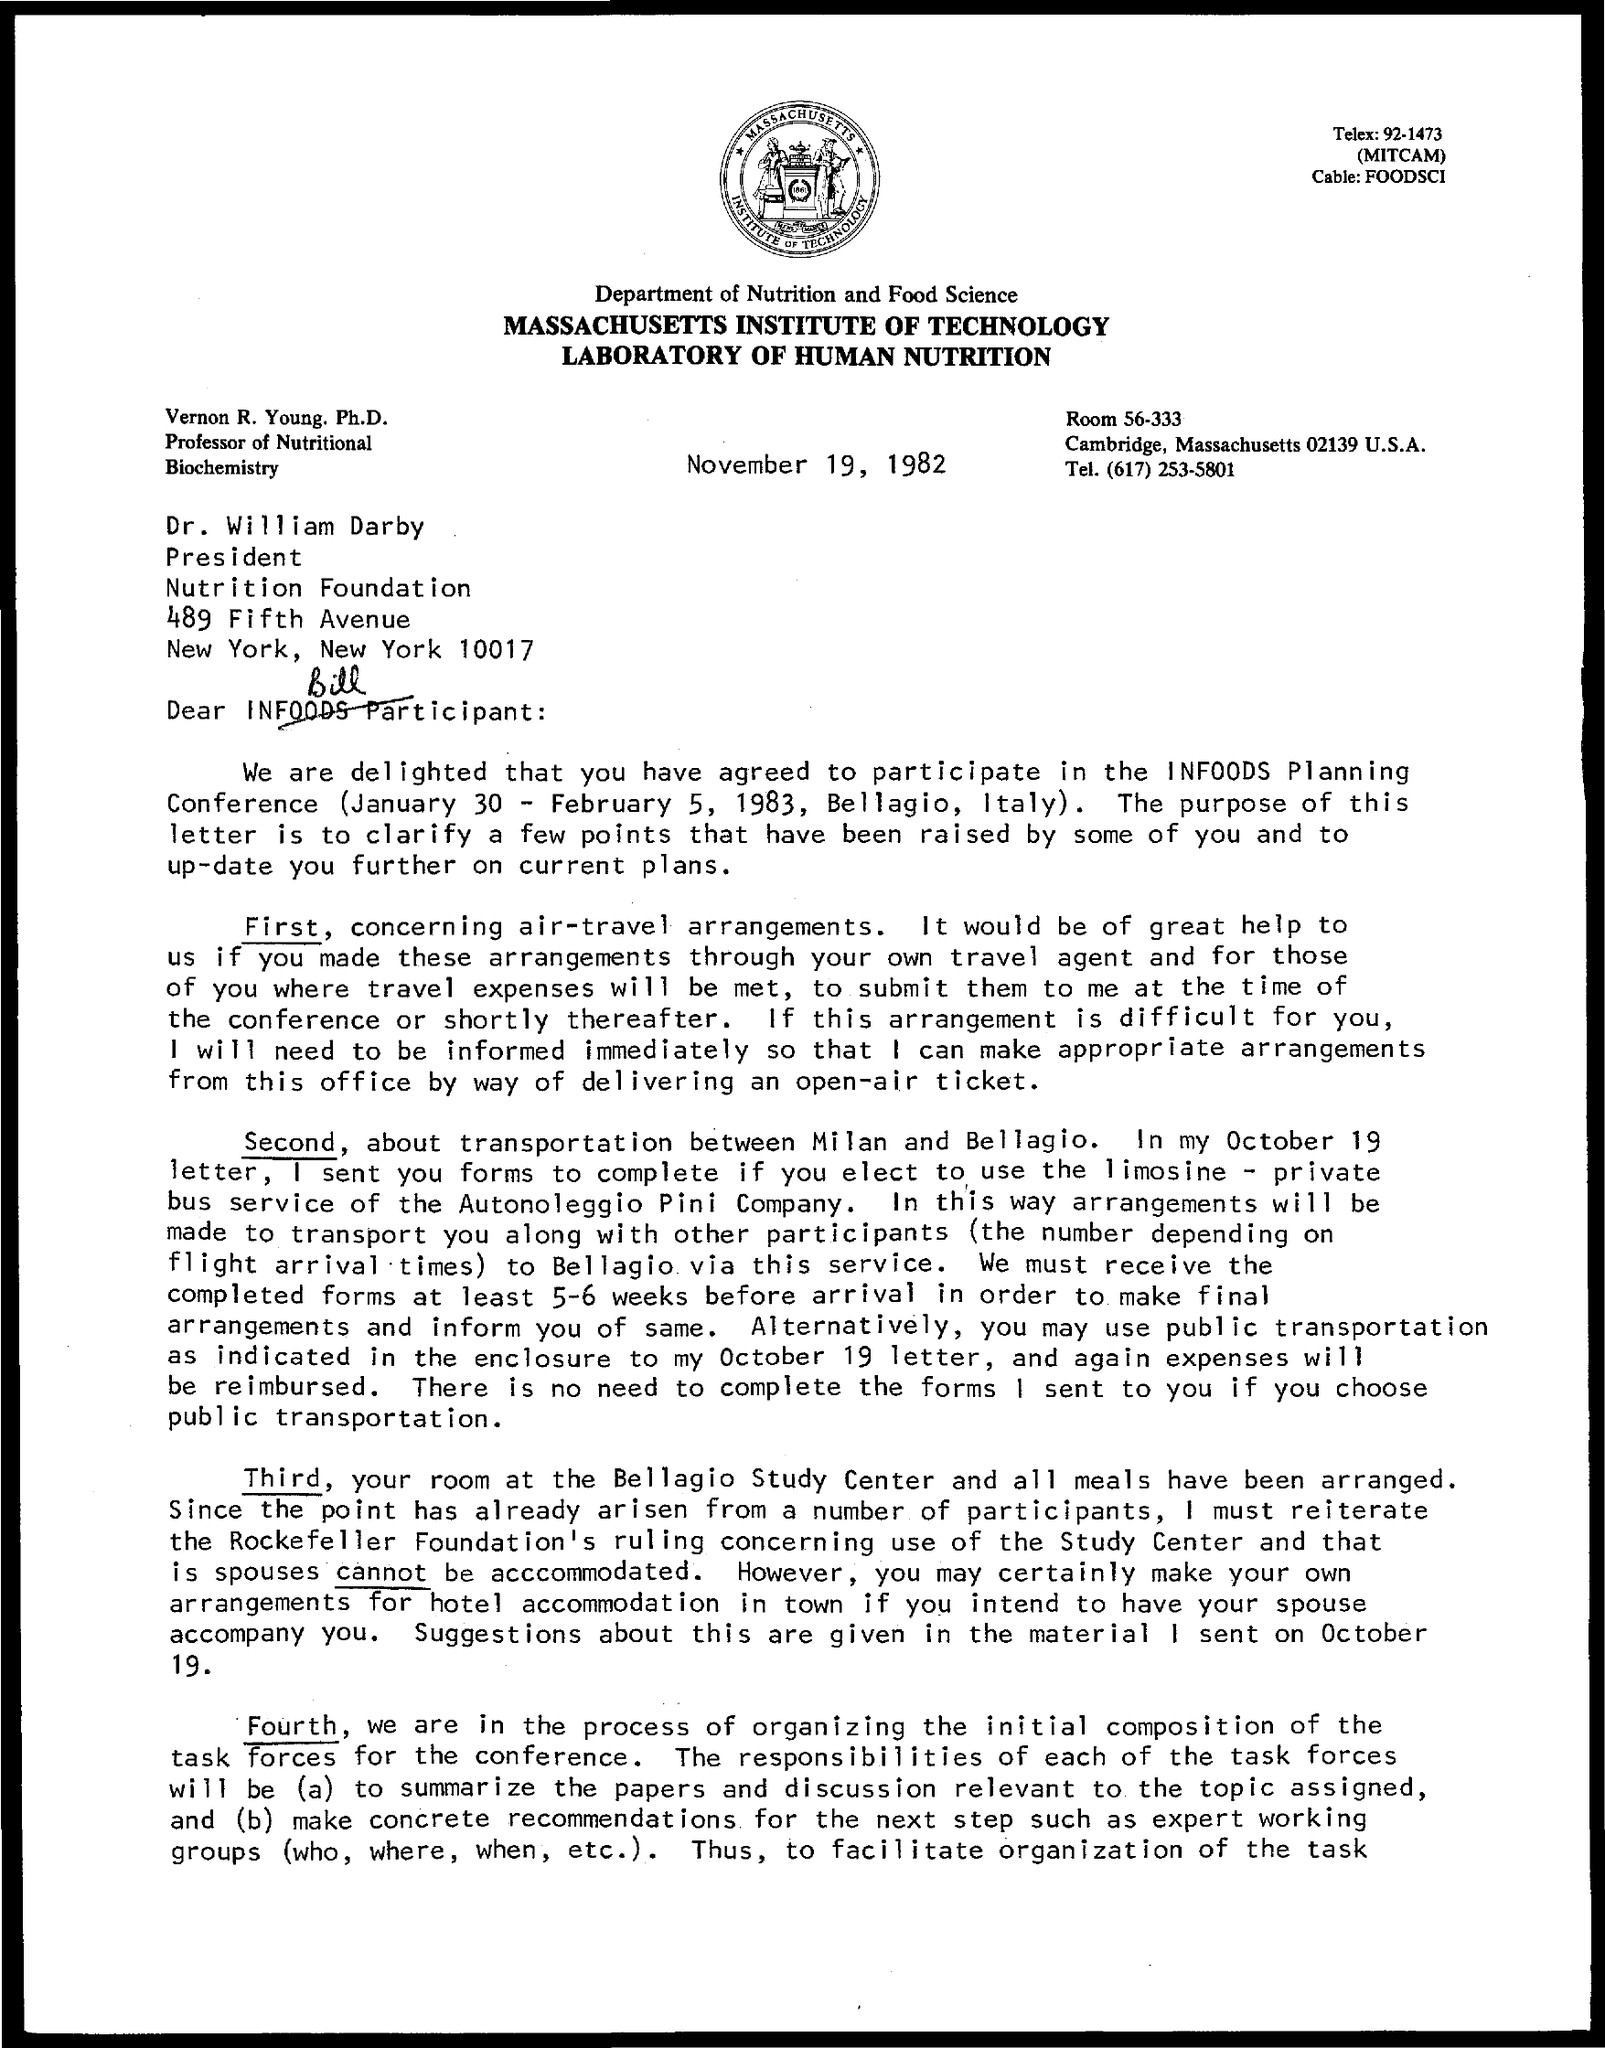Indicate a few pertinent items in this graphic. The Nutrition Foundation is located in New York City. The room number mentioned is 56-333. The president of Nutrition is DR. WILLIAM DARBY. The telephone number mentioned is (617) 253-5801. 